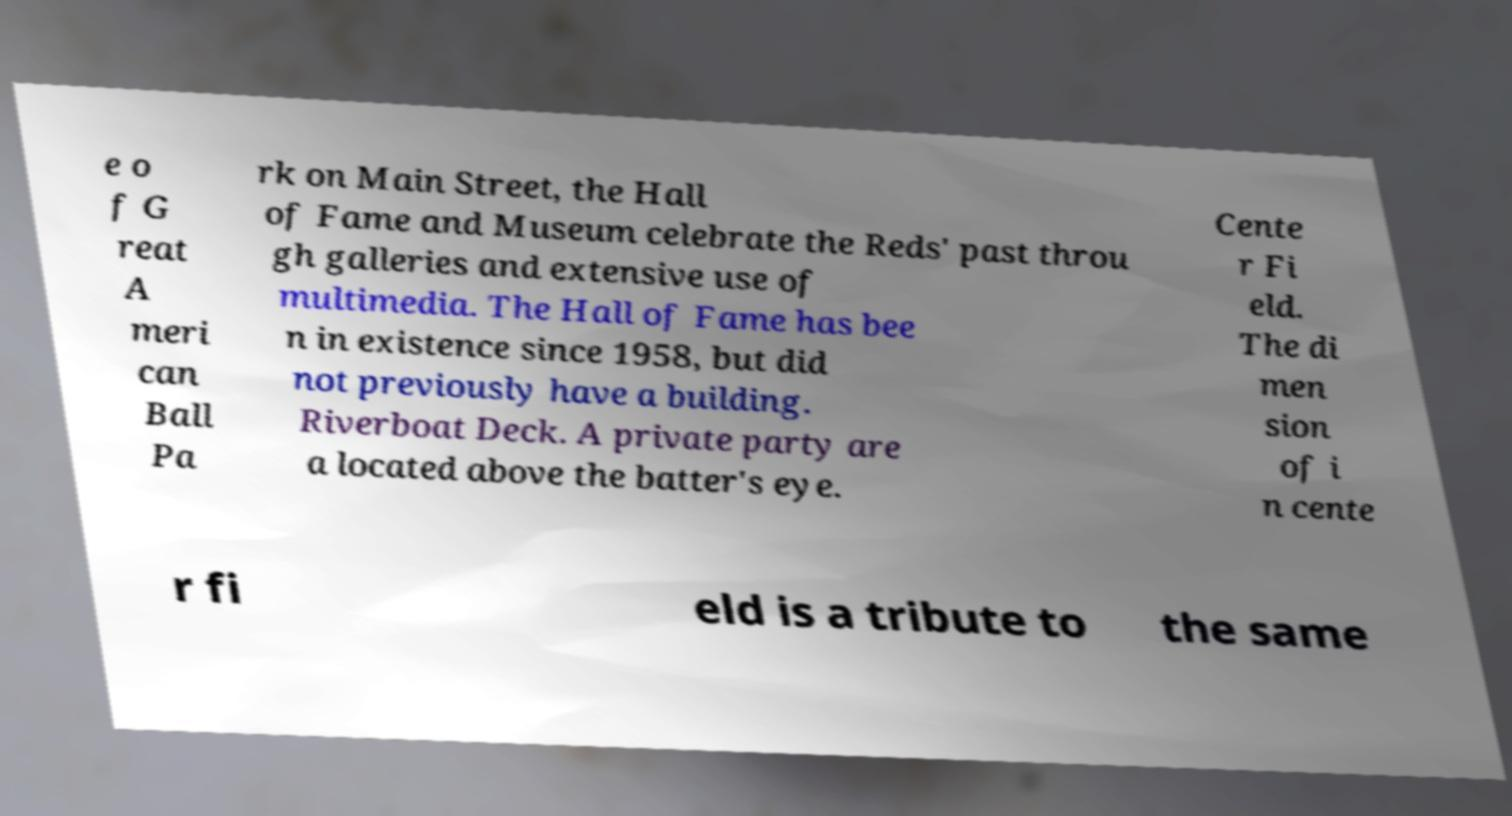Could you extract and type out the text from this image? e o f G reat A meri can Ball Pa rk on Main Street, the Hall of Fame and Museum celebrate the Reds' past throu gh galleries and extensive use of multimedia. The Hall of Fame has bee n in existence since 1958, but did not previously have a building. Riverboat Deck. A private party are a located above the batter's eye. Cente r Fi eld. The di men sion of i n cente r fi eld is a tribute to the same 